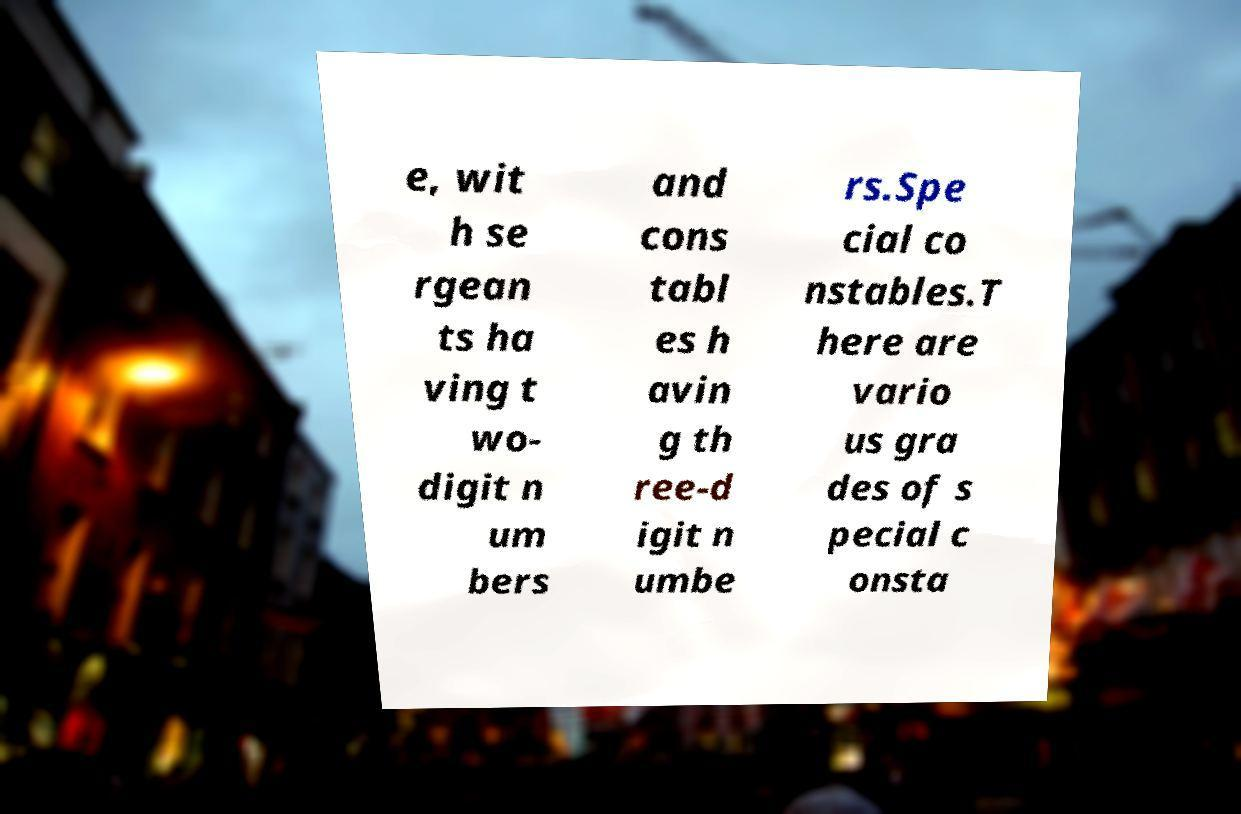I need the written content from this picture converted into text. Can you do that? e, wit h se rgean ts ha ving t wo- digit n um bers and cons tabl es h avin g th ree-d igit n umbe rs.Spe cial co nstables.T here are vario us gra des of s pecial c onsta 